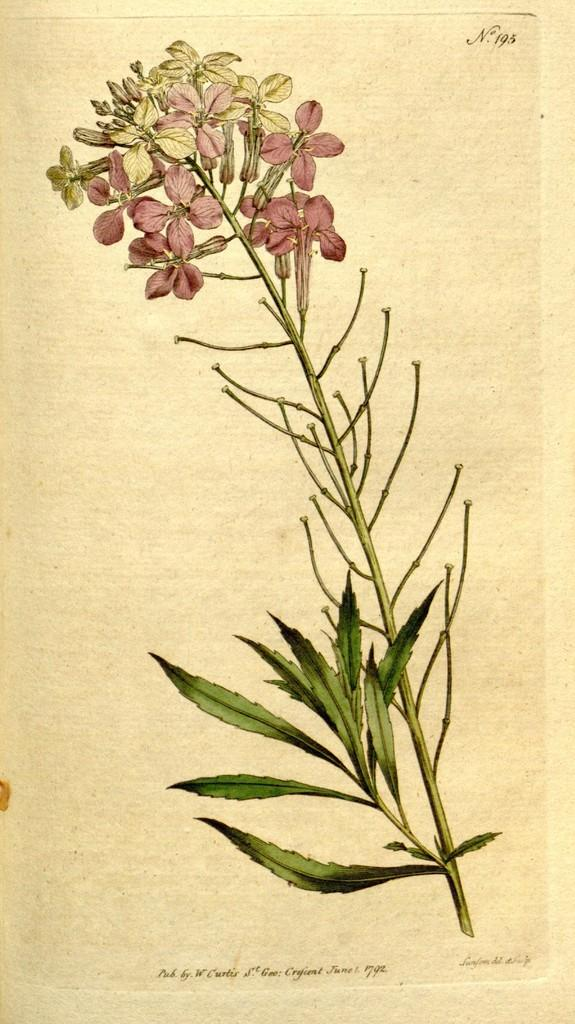What is the main object in the image? There is a branch in the image. What can be found on the branch? The branch contains leaves and flowers. What type of punishment is being administered to the laborer in the image? There is no laborer or punishment present in the image; it only features a branch with leaves and flowers. 